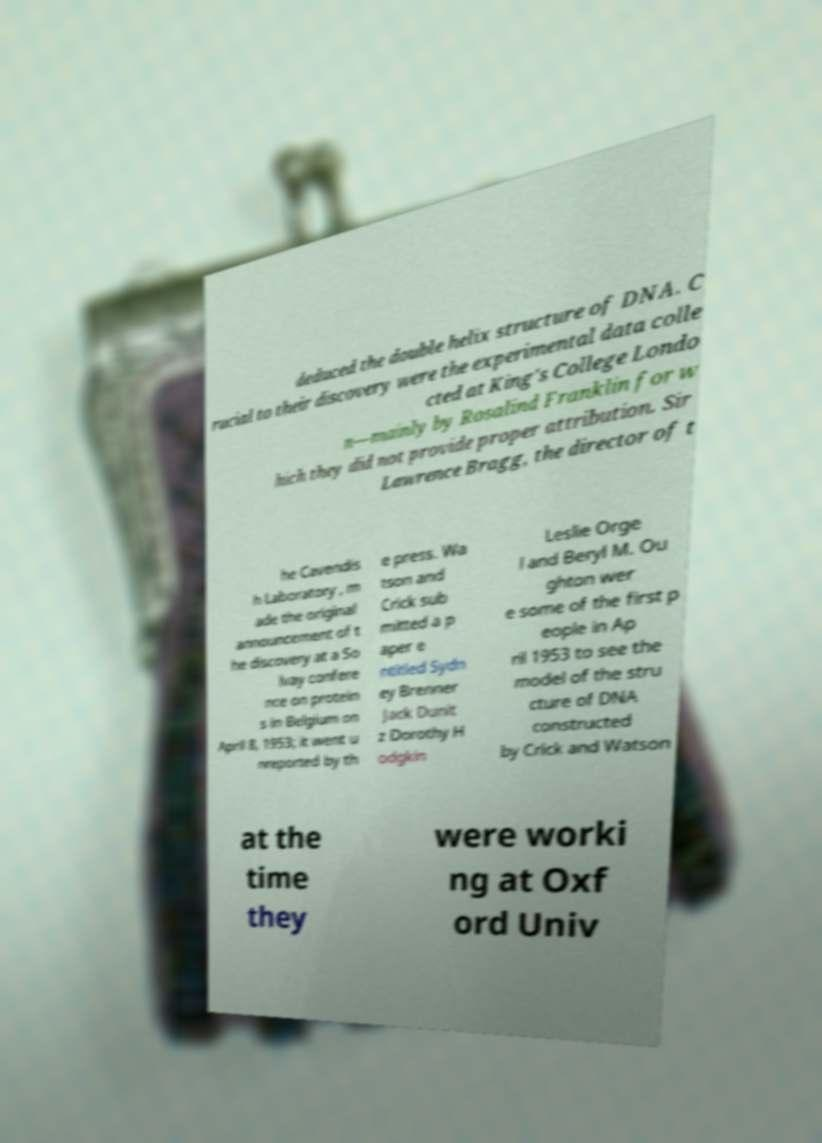What messages or text are displayed in this image? I need them in a readable, typed format. deduced the double helix structure of DNA. C rucial to their discovery were the experimental data colle cted at King's College Londo n—mainly by Rosalind Franklin for w hich they did not provide proper attribution. Sir Lawrence Bragg, the director of t he Cavendis h Laboratory , m ade the original announcement of t he discovery at a So lvay confere nce on protein s in Belgium on April 8, 1953; it went u nreported by th e press. Wa tson and Crick sub mitted a p aper e ntitled Sydn ey Brenner Jack Dunit z Dorothy H odgkin Leslie Orge l and Beryl M. Ou ghton wer e some of the first p eople in Ap ril 1953 to see the model of the stru cture of DNA constructed by Crick and Watson at the time they were worki ng at Oxf ord Univ 